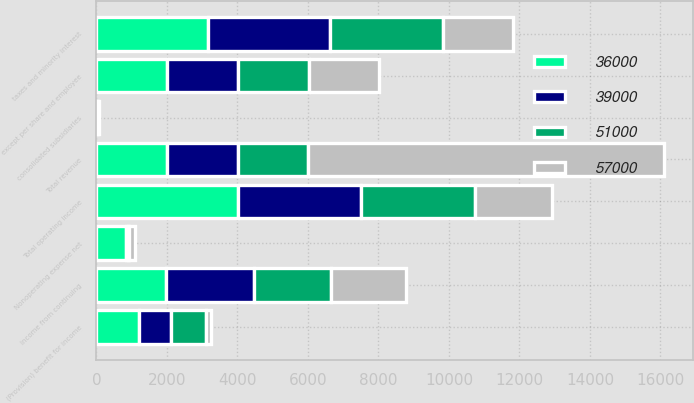Convert chart to OTSL. <chart><loc_0><loc_0><loc_500><loc_500><stacked_bar_chart><ecel><fcel>except per share and employee<fcel>Total revenue<fcel>Total operating income<fcel>Nonoperating expense net<fcel>taxes and minority interest<fcel>(Provision) benefit for income<fcel>consolidated subsidiaries<fcel>Income from continuing<nl><fcel>36000<fcel>2008<fcel>2005<fcel>4010<fcel>847<fcel>3163<fcel>1211<fcel>9<fcel>1961<nl><fcel>39000<fcel>2007<fcel>2005<fcel>3498<fcel>38<fcel>3460<fcel>907<fcel>29<fcel>2524<nl><fcel>51000<fcel>2006<fcel>2005<fcel>3245<fcel>46<fcel>3199<fcel>1003<fcel>19<fcel>2177<nl><fcel>57000<fcel>2005<fcel>10100<fcel>2164<fcel>167<fcel>1997<fcel>125<fcel>15<fcel>2107<nl></chart> 